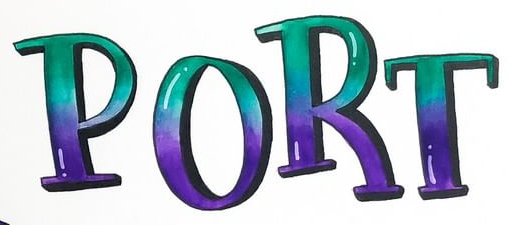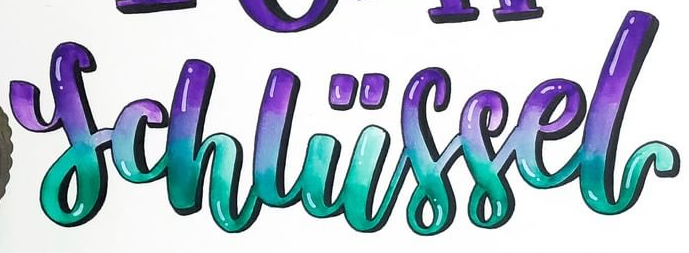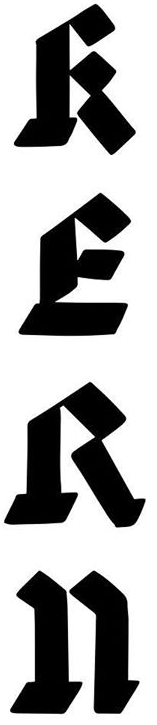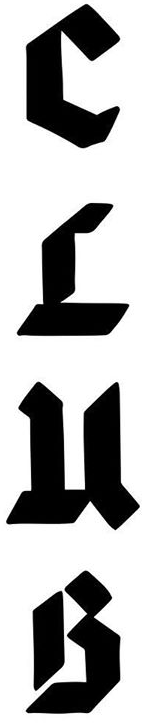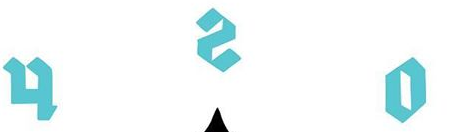What words are shown in these images in order, separated by a semicolon? PORT; schliissel; RERn; CLuB; osh 